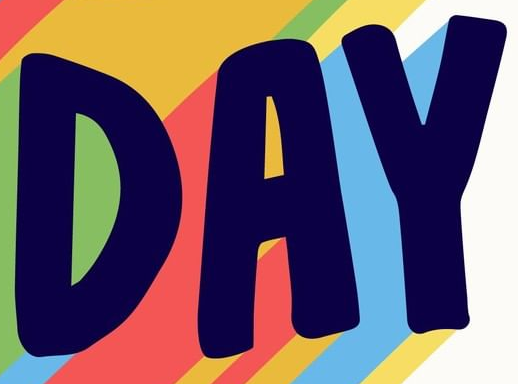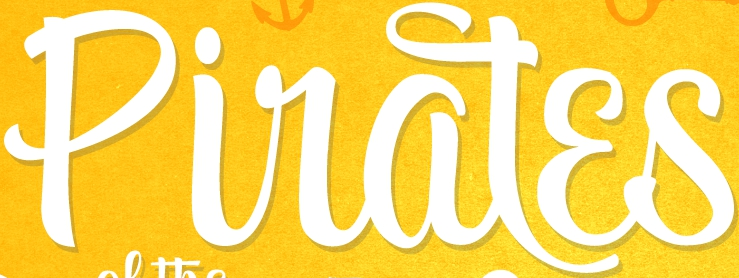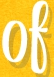Read the text from these images in sequence, separated by a semicolon. DAY; Piratɛs; of 